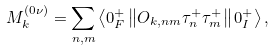Convert formula to latex. <formula><loc_0><loc_0><loc_500><loc_500>M ^ { \left ( 0 \nu \right ) } _ { k } = \sum _ { n , m } \left \langle 0 _ { F } ^ { + } \left \| O _ { k , n m } \tau _ { n } ^ { + } \tau _ { m } ^ { + } \right \| 0 _ { I } ^ { + } \right \rangle ,</formula> 